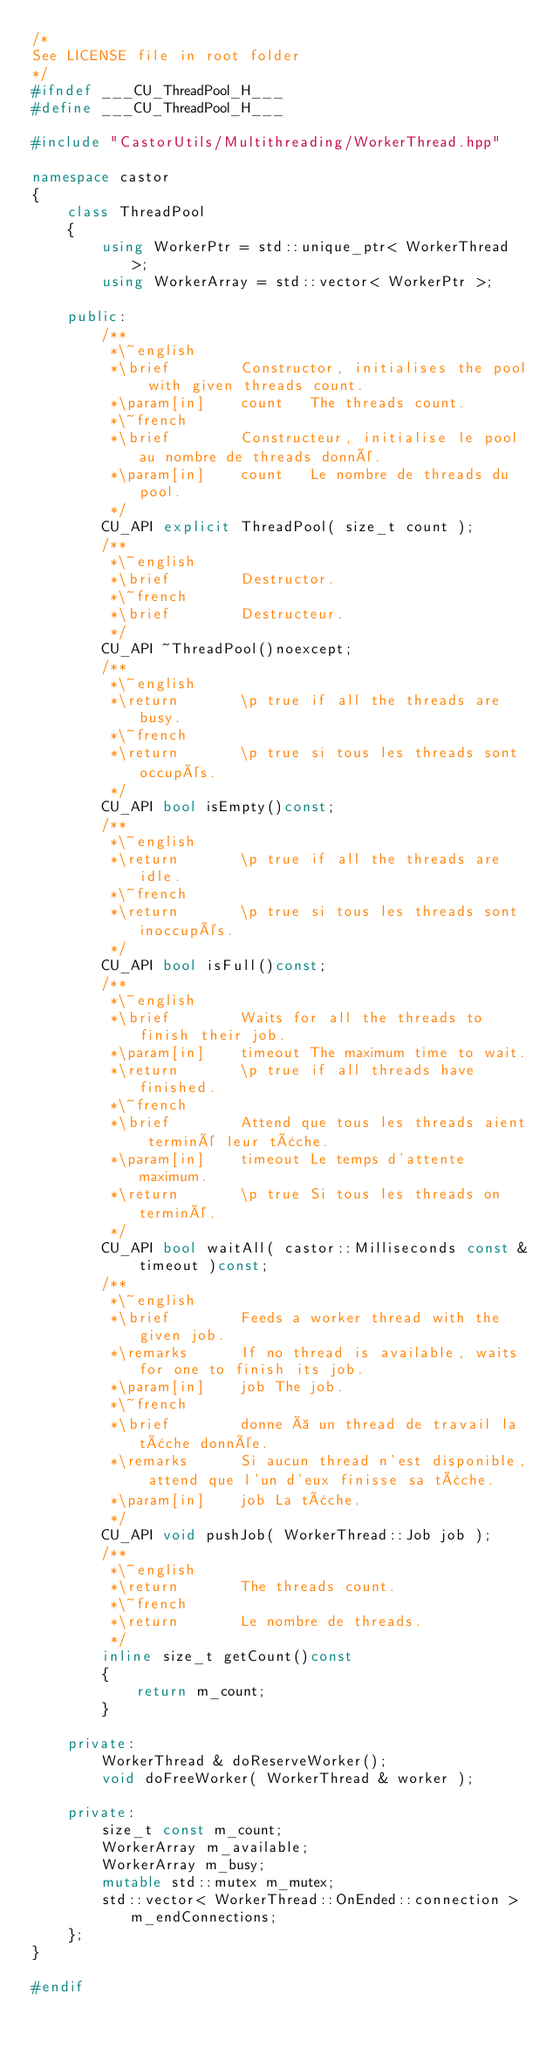<code> <loc_0><loc_0><loc_500><loc_500><_C++_>/*
See LICENSE file in root folder
*/
#ifndef ___CU_ThreadPool_H___
#define ___CU_ThreadPool_H___

#include "CastorUtils/Multithreading/WorkerThread.hpp"

namespace castor
{
	class ThreadPool
	{
		using WorkerPtr = std::unique_ptr< WorkerThread >;
		using WorkerArray = std::vector< WorkerPtr >;

	public:
		/**
		 *\~english
		 *\brief		Constructor, initialises the pool with given threads count.
		 *\param[in]	count	The threads count.
		 *\~french
		 *\brief		Constructeur, initialise le pool au nombre de threads donné.
		 *\param[in]	count	Le nombre de threads du pool.
		 */
		CU_API explicit ThreadPool( size_t count );
		/**
		 *\~english
		 *\brief		Destructor.
		 *\~french
		 *\brief		Destructeur.
		 */
		CU_API ~ThreadPool()noexcept;
		/**
		 *\~english
		 *\return		\p true if all the threads are busy.
		 *\~french
		 *\return		\p true si tous les threads sont occupés.
		 */
		CU_API bool isEmpty()const;
		/**
		 *\~english
		 *\return		\p true if all the threads are idle.
		 *\~french
		 *\return		\p true si tous les threads sont inoccupés.
		 */
		CU_API bool isFull()const;
		/**
		 *\~english
		 *\brief		Waits for all the threads to finish their job.
		 *\param[in]	timeout	The maximum time to wait.
		 *\return		\p true if all threads have finished.
		 *\~french
		 *\brief		Attend que tous les threads aient terminé leur tâche.
		 *\param[in]	timeout	Le temps d'attente maximum.
		 *\return		\p true Si tous les threads on terminé.
		 */
		CU_API bool waitAll( castor::Milliseconds const & timeout )const;
		/**
		 *\~english
		 *\brief		Feeds a worker thread with the given job.
		 *\remarks		If no thread is available, waits for one to finish its job.
		 *\param[in]	job	The job.
		 *\~french
		 *\brief		donne à un thread de travail la tâche donnée.
		 *\remarks		Si aucun thread n'est disponible, attend que l'un d'eux finisse sa tâche.
		 *\param[in]	job	La tâche.
		 */
		CU_API void pushJob( WorkerThread::Job job );
		/**
		 *\~english
		 *\return		The threads count.
		 *\~french
		 *\return		Le nombre de threads.
		 */
		inline size_t getCount()const
		{
			return m_count;
		}

	private:
		WorkerThread & doReserveWorker();
		void doFreeWorker( WorkerThread & worker );

	private:
		size_t const m_count;
		WorkerArray m_available;
		WorkerArray m_busy;
		mutable std::mutex m_mutex;
		std::vector< WorkerThread::OnEnded::connection > m_endConnections;
	};
}

#endif
</code> 